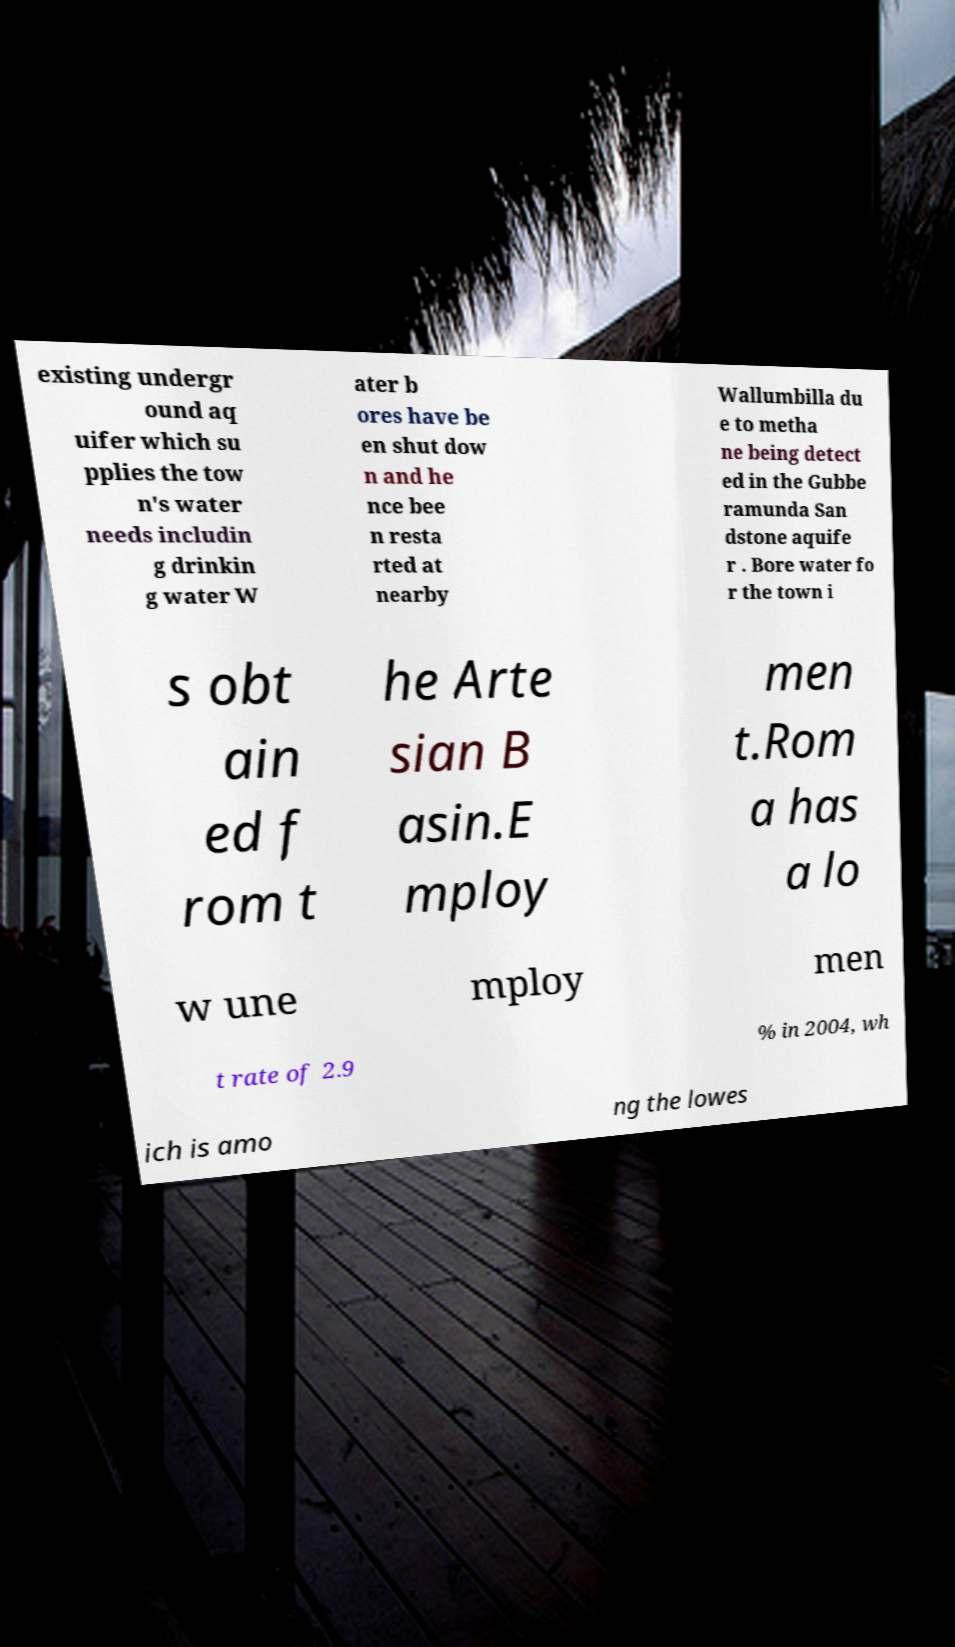Can you accurately transcribe the text from the provided image for me? existing undergr ound aq uifer which su pplies the tow n's water needs includin g drinkin g water W ater b ores have be en shut dow n and he nce bee n resta rted at nearby Wallumbilla du e to metha ne being detect ed in the Gubbe ramunda San dstone aquife r . Bore water fo r the town i s obt ain ed f rom t he Arte sian B asin.E mploy men t.Rom a has a lo w une mploy men t rate of 2.9 % in 2004, wh ich is amo ng the lowes 